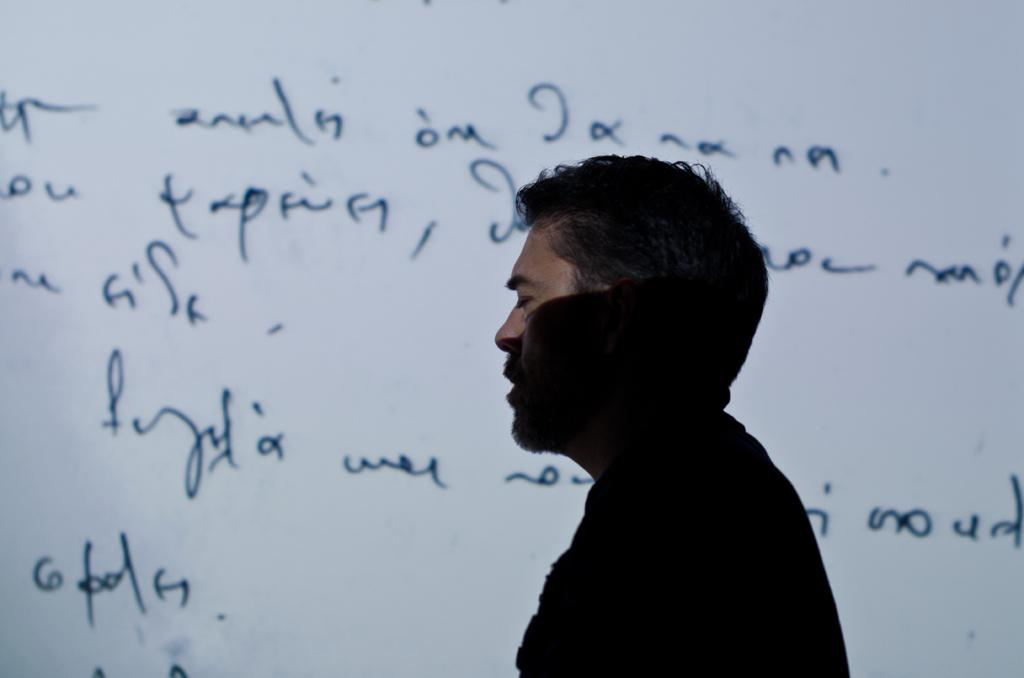What is the main subject of the image? There is a man in the image. What is the man doing in the image? The man appears to be walking. What can be seen in the background of the image? There is a white color object in the background. What is written or depicted on the white object? Text is visible on the white color object, which seems to be a board. How many pies are being sorted with scissors in the image? There are no pies or scissors present in the image. 